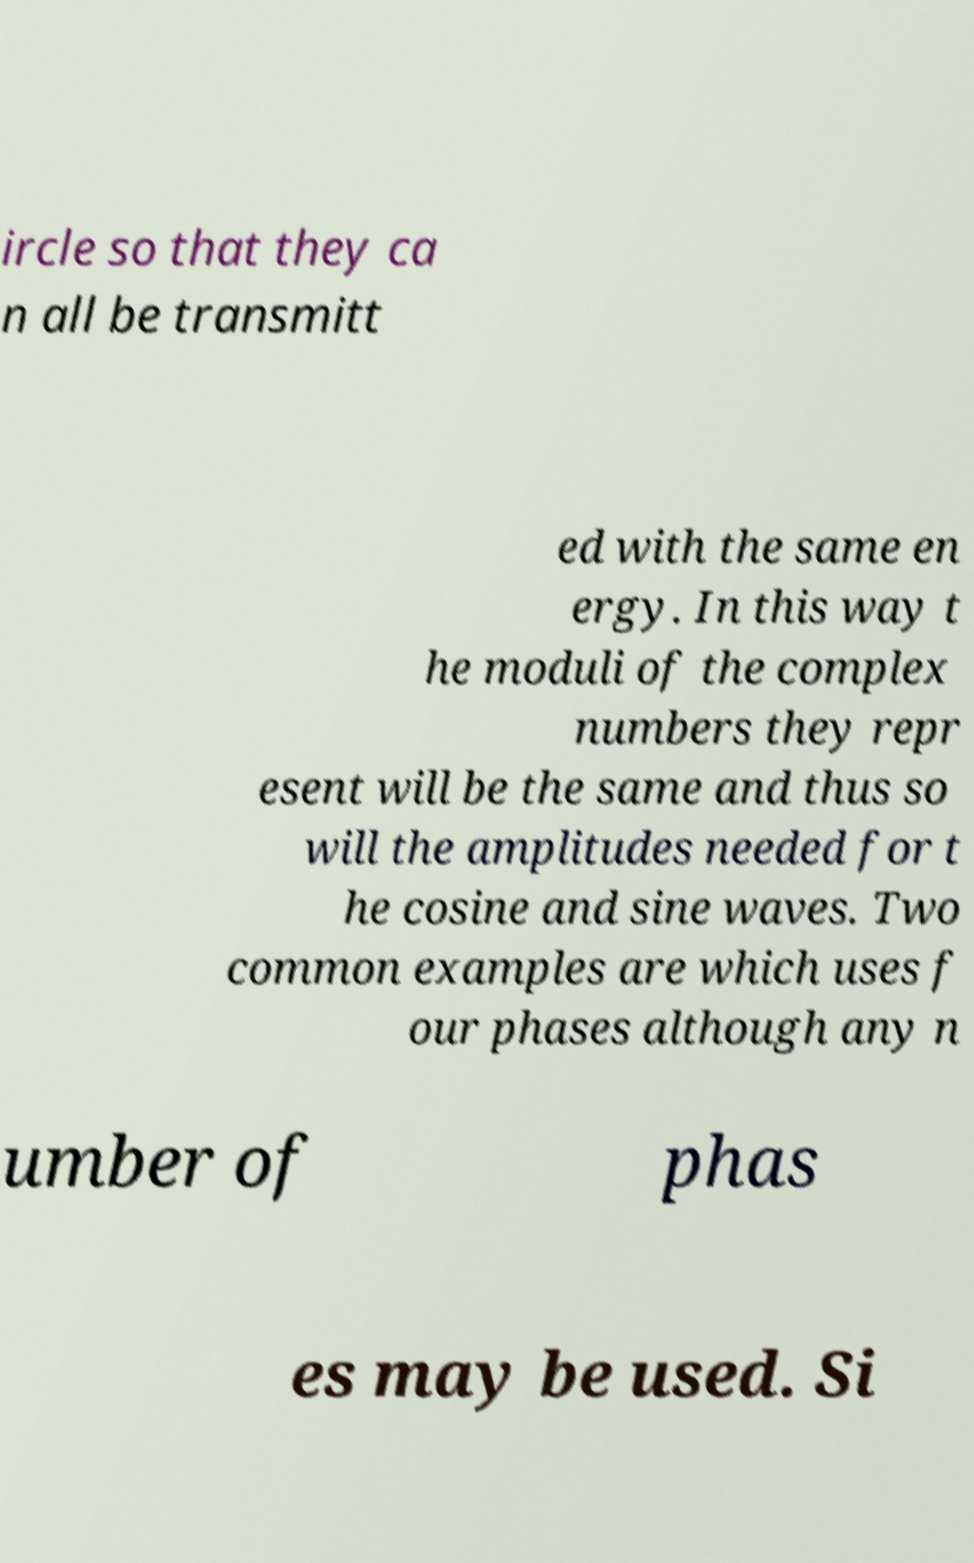What messages or text are displayed in this image? I need them in a readable, typed format. ircle so that they ca n all be transmitt ed with the same en ergy. In this way t he moduli of the complex numbers they repr esent will be the same and thus so will the amplitudes needed for t he cosine and sine waves. Two common examples are which uses f our phases although any n umber of phas es may be used. Si 